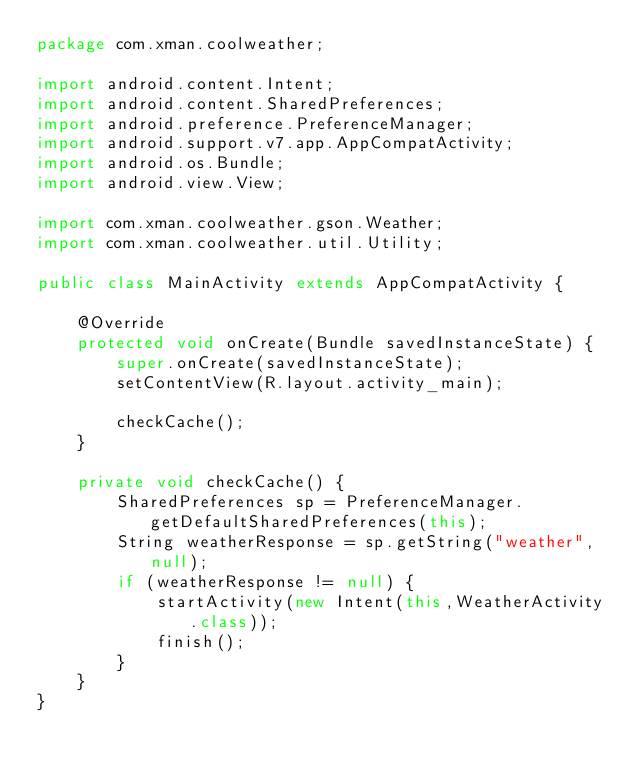Convert code to text. <code><loc_0><loc_0><loc_500><loc_500><_Java_>package com.xman.coolweather;

import android.content.Intent;
import android.content.SharedPreferences;
import android.preference.PreferenceManager;
import android.support.v7.app.AppCompatActivity;
import android.os.Bundle;
import android.view.View;

import com.xman.coolweather.gson.Weather;
import com.xman.coolweather.util.Utility;

public class MainActivity extends AppCompatActivity {

    @Override
    protected void onCreate(Bundle savedInstanceState) {
        super.onCreate(savedInstanceState);
        setContentView(R.layout.activity_main);

        checkCache();
    }

    private void checkCache() {
        SharedPreferences sp = PreferenceManager.getDefaultSharedPreferences(this);
        String weatherResponse = sp.getString("weather", null);
        if (weatherResponse != null) {
            startActivity(new Intent(this,WeatherActivity.class));
            finish();
        }
    }
}
</code> 